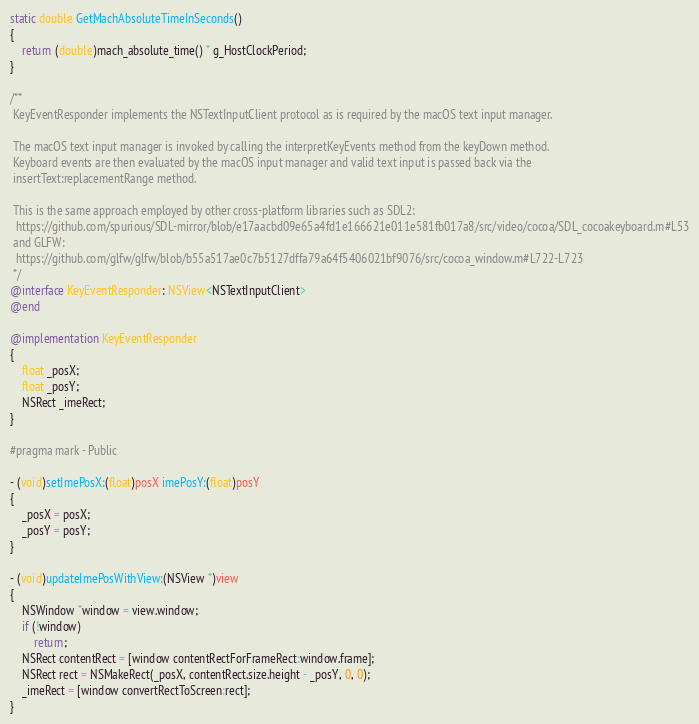Convert code to text. <code><loc_0><loc_0><loc_500><loc_500><_ObjectiveC_>
static double GetMachAbsoluteTimeInSeconds()
{
    return (double)mach_absolute_time() * g_HostClockPeriod;
}

/**
 KeyEventResponder implements the NSTextInputClient protocol as is required by the macOS text input manager.

 The macOS text input manager is invoked by calling the interpretKeyEvents method from the keyDown method.
 Keyboard events are then evaluated by the macOS input manager and valid text input is passed back via the
 insertText:replacementRange method.

 This is the same approach employed by other cross-platform libraries such as SDL2:
  https://github.com/spurious/SDL-mirror/blob/e17aacbd09e65a4fd1e166621e011e581fb017a8/src/video/cocoa/SDL_cocoakeyboard.m#L53
 and GLFW:
  https://github.com/glfw/glfw/blob/b55a517ae0c7b5127dffa79a64f5406021bf9076/src/cocoa_window.m#L722-L723
 */
@interface KeyEventResponder: NSView<NSTextInputClient>
@end

@implementation KeyEventResponder
{
    float _posX;
    float _posY;
    NSRect _imeRect;
}

#pragma mark - Public

- (void)setImePosX:(float)posX imePosY:(float)posY
{
    _posX = posX;
    _posY = posY;
}

- (void)updateImePosWithView:(NSView *)view
{
    NSWindow *window = view.window;
    if (!window)
        return;
    NSRect contentRect = [window contentRectForFrameRect:window.frame];
    NSRect rect = NSMakeRect(_posX, contentRect.size.height - _posY, 0, 0);
    _imeRect = [window convertRectToScreen:rect];
}
</code> 